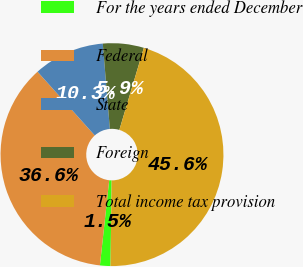<chart> <loc_0><loc_0><loc_500><loc_500><pie_chart><fcel>For the years ended December<fcel>Federal<fcel>State<fcel>Foreign<fcel>Total income tax provision<nl><fcel>1.52%<fcel>36.63%<fcel>10.33%<fcel>5.93%<fcel>45.6%<nl></chart> 